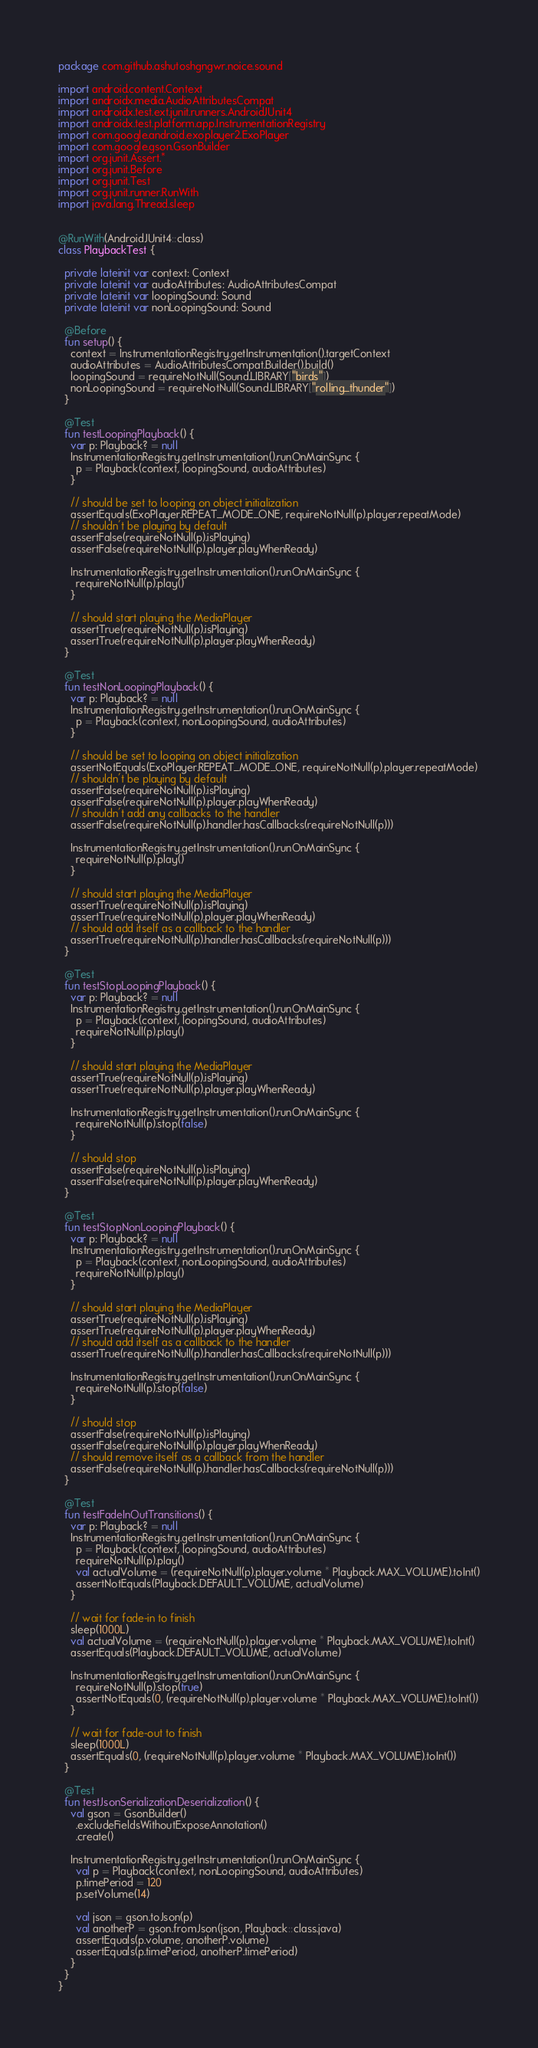<code> <loc_0><loc_0><loc_500><loc_500><_Kotlin_>package com.github.ashutoshgngwr.noice.sound

import android.content.Context
import androidx.media.AudioAttributesCompat
import androidx.test.ext.junit.runners.AndroidJUnit4
import androidx.test.platform.app.InstrumentationRegistry
import com.google.android.exoplayer2.ExoPlayer
import com.google.gson.GsonBuilder
import org.junit.Assert.*
import org.junit.Before
import org.junit.Test
import org.junit.runner.RunWith
import java.lang.Thread.sleep


@RunWith(AndroidJUnit4::class)
class PlaybackTest {

  private lateinit var context: Context
  private lateinit var audioAttributes: AudioAttributesCompat
  private lateinit var loopingSound: Sound
  private lateinit var nonLoopingSound: Sound

  @Before
  fun setup() {
    context = InstrumentationRegistry.getInstrumentation().targetContext
    audioAttributes = AudioAttributesCompat.Builder().build()
    loopingSound = requireNotNull(Sound.LIBRARY["birds"])
    nonLoopingSound = requireNotNull(Sound.LIBRARY["rolling_thunder"])
  }

  @Test
  fun testLoopingPlayback() {
    var p: Playback? = null
    InstrumentationRegistry.getInstrumentation().runOnMainSync {
      p = Playback(context, loopingSound, audioAttributes)
    }

    // should be set to looping on object initialization
    assertEquals(ExoPlayer.REPEAT_MODE_ONE, requireNotNull(p).player.repeatMode)
    // shouldn't be playing by default
    assertFalse(requireNotNull(p).isPlaying)
    assertFalse(requireNotNull(p).player.playWhenReady)

    InstrumentationRegistry.getInstrumentation().runOnMainSync {
      requireNotNull(p).play()
    }

    // should start playing the MediaPlayer
    assertTrue(requireNotNull(p).isPlaying)
    assertTrue(requireNotNull(p).player.playWhenReady)
  }

  @Test
  fun testNonLoopingPlayback() {
    var p: Playback? = null
    InstrumentationRegistry.getInstrumentation().runOnMainSync {
      p = Playback(context, nonLoopingSound, audioAttributes)
    }

    // should be set to looping on object initialization
    assertNotEquals(ExoPlayer.REPEAT_MODE_ONE, requireNotNull(p).player.repeatMode)
    // shouldn't be playing by default
    assertFalse(requireNotNull(p).isPlaying)
    assertFalse(requireNotNull(p).player.playWhenReady)
    // shouldn't add any callbacks to the handler
    assertFalse(requireNotNull(p).handler.hasCallbacks(requireNotNull(p)))

    InstrumentationRegistry.getInstrumentation().runOnMainSync {
      requireNotNull(p).play()
    }

    // should start playing the MediaPlayer
    assertTrue(requireNotNull(p).isPlaying)
    assertTrue(requireNotNull(p).player.playWhenReady)
    // should add itself as a callback to the handler
    assertTrue(requireNotNull(p).handler.hasCallbacks(requireNotNull(p)))
  }

  @Test
  fun testStopLoopingPlayback() {
    var p: Playback? = null
    InstrumentationRegistry.getInstrumentation().runOnMainSync {
      p = Playback(context, loopingSound, audioAttributes)
      requireNotNull(p).play()
    }

    // should start playing the MediaPlayer
    assertTrue(requireNotNull(p).isPlaying)
    assertTrue(requireNotNull(p).player.playWhenReady)

    InstrumentationRegistry.getInstrumentation().runOnMainSync {
      requireNotNull(p).stop(false)
    }

    // should stop
    assertFalse(requireNotNull(p).isPlaying)
    assertFalse(requireNotNull(p).player.playWhenReady)
  }

  @Test
  fun testStopNonLoopingPlayback() {
    var p: Playback? = null
    InstrumentationRegistry.getInstrumentation().runOnMainSync {
      p = Playback(context, nonLoopingSound, audioAttributes)
      requireNotNull(p).play()
    }

    // should start playing the MediaPlayer
    assertTrue(requireNotNull(p).isPlaying)
    assertTrue(requireNotNull(p).player.playWhenReady)
    // should add itself as a callback to the handler
    assertTrue(requireNotNull(p).handler.hasCallbacks(requireNotNull(p)))

    InstrumentationRegistry.getInstrumentation().runOnMainSync {
      requireNotNull(p).stop(false)
    }

    // should stop
    assertFalse(requireNotNull(p).isPlaying)
    assertFalse(requireNotNull(p).player.playWhenReady)
    // should remove itself as a callback from the handler
    assertFalse(requireNotNull(p).handler.hasCallbacks(requireNotNull(p)))
  }

  @Test
  fun testFadeInOutTransitions() {
    var p: Playback? = null
    InstrumentationRegistry.getInstrumentation().runOnMainSync {
      p = Playback(context, loopingSound, audioAttributes)
      requireNotNull(p).play()
      val actualVolume = (requireNotNull(p).player.volume * Playback.MAX_VOLUME).toInt()
      assertNotEquals(Playback.DEFAULT_VOLUME, actualVolume)
    }

    // wait for fade-in to finish
    sleep(1000L)
    val actualVolume = (requireNotNull(p).player.volume * Playback.MAX_VOLUME).toInt()
    assertEquals(Playback.DEFAULT_VOLUME, actualVolume)

    InstrumentationRegistry.getInstrumentation().runOnMainSync {
      requireNotNull(p).stop(true)
      assertNotEquals(0, (requireNotNull(p).player.volume * Playback.MAX_VOLUME).toInt())
    }

    // wait for fade-out to finish
    sleep(1000L)
    assertEquals(0, (requireNotNull(p).player.volume * Playback.MAX_VOLUME).toInt())
  }

  @Test
  fun testJsonSerializationDeserialization() {
    val gson = GsonBuilder()
      .excludeFieldsWithoutExposeAnnotation()
      .create()

    InstrumentationRegistry.getInstrumentation().runOnMainSync {
      val p = Playback(context, nonLoopingSound, audioAttributes)
      p.timePeriod = 120
      p.setVolume(14)

      val json = gson.toJson(p)
      val anotherP = gson.fromJson(json, Playback::class.java)
      assertEquals(p.volume, anotherP.volume)
      assertEquals(p.timePeriod, anotherP.timePeriod)
    }
  }
}
</code> 